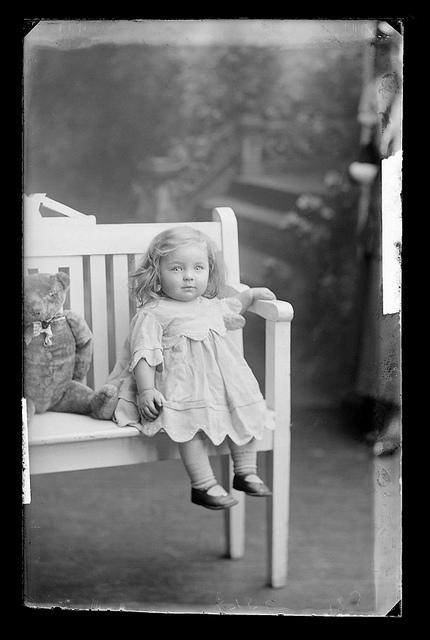Is this photo indoors?
Answer briefly. Yes. What is sitting next to the girl?
Short answer required. Teddy bear. What is on her head?
Answer briefly. Hair. Is the little kid skiing?
Give a very brief answer. No. Is the photo color sepia?
Quick response, please. No. On what side does the woman in the picture part her hair?
Keep it brief. Left. Is the little girl happy?
Keep it brief. No. Is this a recent photo?
Concise answer only. No. Is she crossing her right leg over her left?
Answer briefly. No. 